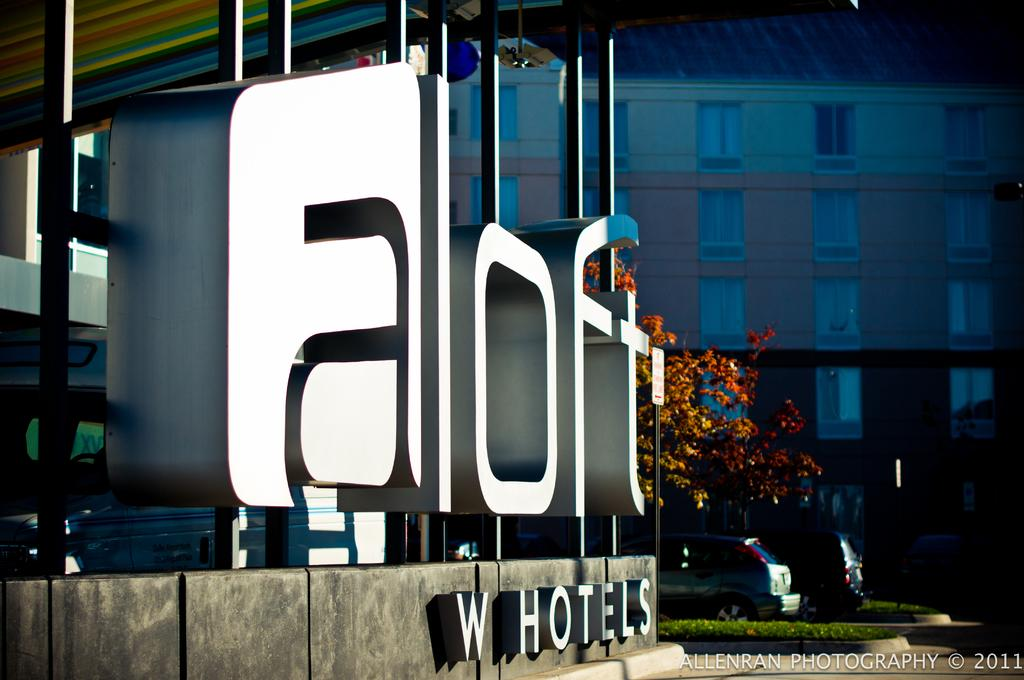What objects can be seen in the image? There are boards, a tree, and vehicles in the image. What type of structure is visible in the background of the image? There is a building with windows in the background of the image. Can you describe the activity of the squirrel on the tree in the image? There is no squirrel present in the image; it only features boards, a tree, vehicles, and a building with windows in the background. 